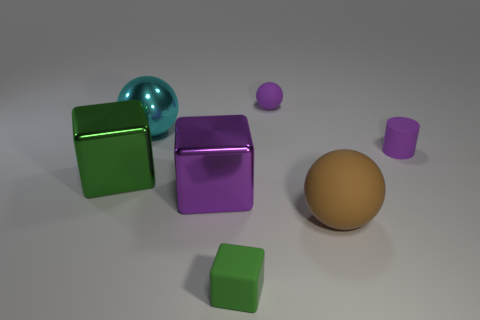Subtract all tiny blocks. How many blocks are left? 2 Subtract all gray spheres. How many green cubes are left? 2 Subtract all green blocks. How many blocks are left? 1 Subtract 1 balls. How many balls are left? 2 Add 2 large purple metal cubes. How many objects exist? 9 Subtract all cubes. How many objects are left? 4 Subtract all yellow balls. Subtract all gray cubes. How many balls are left? 3 Subtract all big yellow objects. Subtract all metallic blocks. How many objects are left? 5 Add 2 cyan metallic objects. How many cyan metallic objects are left? 3 Add 5 gray things. How many gray things exist? 5 